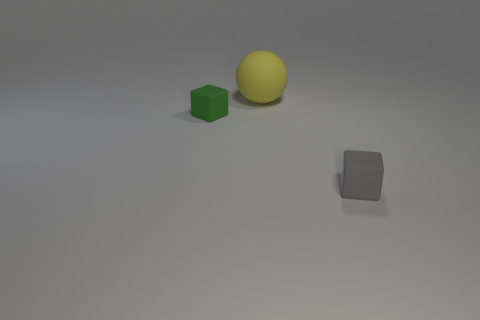Is there anything else that has the same size as the yellow thing?
Provide a short and direct response. No. There is a green thing that is the same material as the big yellow sphere; what shape is it?
Offer a terse response. Cube. There is a matte thing that is in front of the rubber block that is to the left of the small gray matte object; what is its size?
Provide a short and direct response. Small. What number of small objects are gray cubes or green matte blocks?
Provide a succinct answer. 2. What number of other things are the same color as the big rubber sphere?
Ensure brevity in your answer.  0. Does the matte block that is right of the large yellow matte thing have the same size as the matte thing that is behind the tiny green cube?
Offer a terse response. No. Do the yellow object and the small cube that is to the left of the large matte thing have the same material?
Give a very brief answer. Yes. Are there more big spheres that are to the left of the large rubber sphere than gray rubber things right of the gray block?
Your answer should be very brief. No. There is a tiny object that is on the right side of the green matte object that is left of the gray cube; what is its color?
Make the answer very short. Gray. How many blocks are either gray matte things or cyan metal things?
Offer a terse response. 1. 